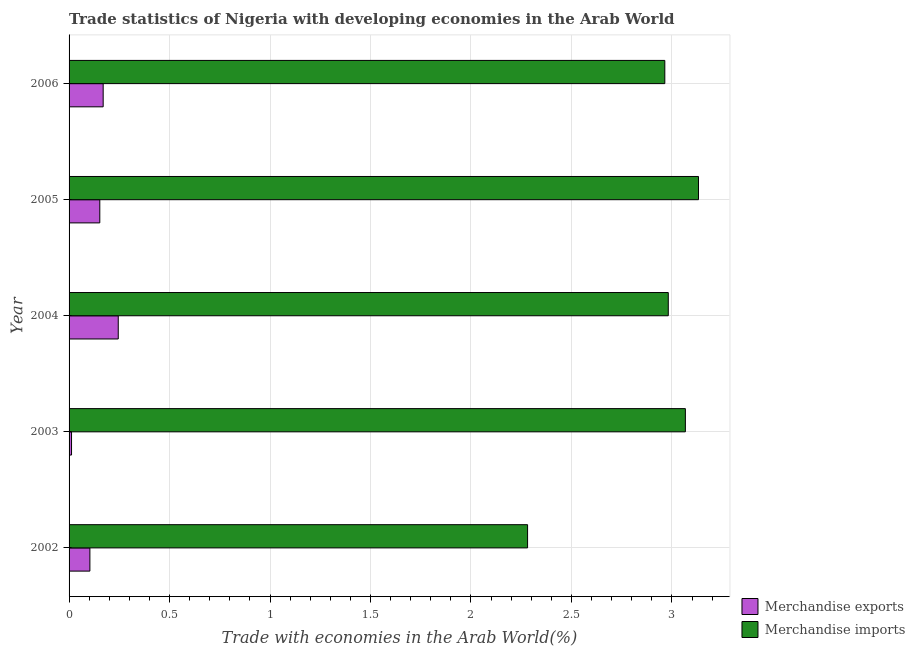How many bars are there on the 3rd tick from the top?
Provide a succinct answer. 2. What is the label of the 2nd group of bars from the top?
Give a very brief answer. 2005. In how many cases, is the number of bars for a given year not equal to the number of legend labels?
Your answer should be compact. 0. What is the merchandise exports in 2006?
Make the answer very short. 0.17. Across all years, what is the maximum merchandise exports?
Offer a very short reply. 0.24. Across all years, what is the minimum merchandise exports?
Your response must be concise. 0.01. In which year was the merchandise imports minimum?
Your answer should be compact. 2002. What is the total merchandise imports in the graph?
Your answer should be very brief. 14.43. What is the difference between the merchandise imports in 2004 and that in 2005?
Provide a succinct answer. -0.15. What is the difference between the merchandise exports in 2004 and the merchandise imports in 2003?
Give a very brief answer. -2.82. What is the average merchandise imports per year?
Provide a short and direct response. 2.89. In the year 2003, what is the difference between the merchandise exports and merchandise imports?
Offer a terse response. -3.06. What is the ratio of the merchandise exports in 2003 to that in 2006?
Make the answer very short. 0.07. Is the merchandise exports in 2002 less than that in 2003?
Provide a succinct answer. No. What is the difference between the highest and the second highest merchandise exports?
Your response must be concise. 0.07. Is the sum of the merchandise imports in 2003 and 2006 greater than the maximum merchandise exports across all years?
Offer a very short reply. Yes. What does the 1st bar from the top in 2005 represents?
Your answer should be compact. Merchandise imports. Are all the bars in the graph horizontal?
Offer a very short reply. Yes. How many years are there in the graph?
Your response must be concise. 5. What is the difference between two consecutive major ticks on the X-axis?
Offer a very short reply. 0.5. Are the values on the major ticks of X-axis written in scientific E-notation?
Your answer should be very brief. No. Does the graph contain grids?
Provide a short and direct response. Yes. Where does the legend appear in the graph?
Provide a short and direct response. Bottom right. How many legend labels are there?
Give a very brief answer. 2. What is the title of the graph?
Provide a short and direct response. Trade statistics of Nigeria with developing economies in the Arab World. Does "Long-term debt" appear as one of the legend labels in the graph?
Your answer should be compact. No. What is the label or title of the X-axis?
Your answer should be compact. Trade with economies in the Arab World(%). What is the label or title of the Y-axis?
Ensure brevity in your answer.  Year. What is the Trade with economies in the Arab World(%) of Merchandise exports in 2002?
Ensure brevity in your answer.  0.1. What is the Trade with economies in the Arab World(%) of Merchandise imports in 2002?
Your answer should be very brief. 2.28. What is the Trade with economies in the Arab World(%) in Merchandise exports in 2003?
Give a very brief answer. 0.01. What is the Trade with economies in the Arab World(%) of Merchandise imports in 2003?
Offer a very short reply. 3.07. What is the Trade with economies in the Arab World(%) of Merchandise exports in 2004?
Offer a very short reply. 0.24. What is the Trade with economies in the Arab World(%) in Merchandise imports in 2004?
Offer a very short reply. 2.98. What is the Trade with economies in the Arab World(%) in Merchandise exports in 2005?
Keep it short and to the point. 0.15. What is the Trade with economies in the Arab World(%) in Merchandise imports in 2005?
Give a very brief answer. 3.13. What is the Trade with economies in the Arab World(%) of Merchandise exports in 2006?
Your response must be concise. 0.17. What is the Trade with economies in the Arab World(%) in Merchandise imports in 2006?
Offer a very short reply. 2.96. Across all years, what is the maximum Trade with economies in the Arab World(%) in Merchandise exports?
Make the answer very short. 0.24. Across all years, what is the maximum Trade with economies in the Arab World(%) in Merchandise imports?
Offer a terse response. 3.13. Across all years, what is the minimum Trade with economies in the Arab World(%) of Merchandise exports?
Your answer should be compact. 0.01. Across all years, what is the minimum Trade with economies in the Arab World(%) in Merchandise imports?
Your response must be concise. 2.28. What is the total Trade with economies in the Arab World(%) in Merchandise exports in the graph?
Your answer should be compact. 0.68. What is the total Trade with economies in the Arab World(%) of Merchandise imports in the graph?
Your response must be concise. 14.43. What is the difference between the Trade with economies in the Arab World(%) in Merchandise exports in 2002 and that in 2003?
Your answer should be compact. 0.09. What is the difference between the Trade with economies in the Arab World(%) of Merchandise imports in 2002 and that in 2003?
Keep it short and to the point. -0.79. What is the difference between the Trade with economies in the Arab World(%) in Merchandise exports in 2002 and that in 2004?
Ensure brevity in your answer.  -0.14. What is the difference between the Trade with economies in the Arab World(%) in Merchandise imports in 2002 and that in 2004?
Make the answer very short. -0.7. What is the difference between the Trade with economies in the Arab World(%) in Merchandise exports in 2002 and that in 2005?
Your response must be concise. -0.05. What is the difference between the Trade with economies in the Arab World(%) of Merchandise imports in 2002 and that in 2005?
Offer a terse response. -0.85. What is the difference between the Trade with economies in the Arab World(%) of Merchandise exports in 2002 and that in 2006?
Make the answer very short. -0.07. What is the difference between the Trade with economies in the Arab World(%) in Merchandise imports in 2002 and that in 2006?
Give a very brief answer. -0.68. What is the difference between the Trade with economies in the Arab World(%) of Merchandise exports in 2003 and that in 2004?
Ensure brevity in your answer.  -0.23. What is the difference between the Trade with economies in the Arab World(%) in Merchandise imports in 2003 and that in 2004?
Offer a terse response. 0.09. What is the difference between the Trade with economies in the Arab World(%) in Merchandise exports in 2003 and that in 2005?
Your response must be concise. -0.14. What is the difference between the Trade with economies in the Arab World(%) in Merchandise imports in 2003 and that in 2005?
Make the answer very short. -0.07. What is the difference between the Trade with economies in the Arab World(%) in Merchandise exports in 2003 and that in 2006?
Provide a short and direct response. -0.16. What is the difference between the Trade with economies in the Arab World(%) in Merchandise imports in 2003 and that in 2006?
Offer a terse response. 0.1. What is the difference between the Trade with economies in the Arab World(%) in Merchandise exports in 2004 and that in 2005?
Keep it short and to the point. 0.09. What is the difference between the Trade with economies in the Arab World(%) in Merchandise imports in 2004 and that in 2005?
Your response must be concise. -0.15. What is the difference between the Trade with economies in the Arab World(%) of Merchandise exports in 2004 and that in 2006?
Provide a short and direct response. 0.07. What is the difference between the Trade with economies in the Arab World(%) of Merchandise imports in 2004 and that in 2006?
Offer a terse response. 0.02. What is the difference between the Trade with economies in the Arab World(%) in Merchandise exports in 2005 and that in 2006?
Provide a short and direct response. -0.02. What is the difference between the Trade with economies in the Arab World(%) of Merchandise imports in 2005 and that in 2006?
Give a very brief answer. 0.17. What is the difference between the Trade with economies in the Arab World(%) of Merchandise exports in 2002 and the Trade with economies in the Arab World(%) of Merchandise imports in 2003?
Your answer should be compact. -2.96. What is the difference between the Trade with economies in the Arab World(%) of Merchandise exports in 2002 and the Trade with economies in the Arab World(%) of Merchandise imports in 2004?
Keep it short and to the point. -2.88. What is the difference between the Trade with economies in the Arab World(%) in Merchandise exports in 2002 and the Trade with economies in the Arab World(%) in Merchandise imports in 2005?
Offer a terse response. -3.03. What is the difference between the Trade with economies in the Arab World(%) of Merchandise exports in 2002 and the Trade with economies in the Arab World(%) of Merchandise imports in 2006?
Your response must be concise. -2.86. What is the difference between the Trade with economies in the Arab World(%) of Merchandise exports in 2003 and the Trade with economies in the Arab World(%) of Merchandise imports in 2004?
Make the answer very short. -2.97. What is the difference between the Trade with economies in the Arab World(%) of Merchandise exports in 2003 and the Trade with economies in the Arab World(%) of Merchandise imports in 2005?
Offer a terse response. -3.12. What is the difference between the Trade with economies in the Arab World(%) in Merchandise exports in 2003 and the Trade with economies in the Arab World(%) in Merchandise imports in 2006?
Offer a terse response. -2.95. What is the difference between the Trade with economies in the Arab World(%) in Merchandise exports in 2004 and the Trade with economies in the Arab World(%) in Merchandise imports in 2005?
Give a very brief answer. -2.89. What is the difference between the Trade with economies in the Arab World(%) in Merchandise exports in 2004 and the Trade with economies in the Arab World(%) in Merchandise imports in 2006?
Offer a terse response. -2.72. What is the difference between the Trade with economies in the Arab World(%) in Merchandise exports in 2005 and the Trade with economies in the Arab World(%) in Merchandise imports in 2006?
Keep it short and to the point. -2.81. What is the average Trade with economies in the Arab World(%) of Merchandise exports per year?
Your answer should be very brief. 0.14. What is the average Trade with economies in the Arab World(%) in Merchandise imports per year?
Your answer should be compact. 2.89. In the year 2002, what is the difference between the Trade with economies in the Arab World(%) in Merchandise exports and Trade with economies in the Arab World(%) in Merchandise imports?
Provide a short and direct response. -2.18. In the year 2003, what is the difference between the Trade with economies in the Arab World(%) of Merchandise exports and Trade with economies in the Arab World(%) of Merchandise imports?
Give a very brief answer. -3.05. In the year 2004, what is the difference between the Trade with economies in the Arab World(%) of Merchandise exports and Trade with economies in the Arab World(%) of Merchandise imports?
Keep it short and to the point. -2.74. In the year 2005, what is the difference between the Trade with economies in the Arab World(%) of Merchandise exports and Trade with economies in the Arab World(%) of Merchandise imports?
Provide a succinct answer. -2.98. In the year 2006, what is the difference between the Trade with economies in the Arab World(%) in Merchandise exports and Trade with economies in the Arab World(%) in Merchandise imports?
Give a very brief answer. -2.79. What is the ratio of the Trade with economies in the Arab World(%) of Merchandise exports in 2002 to that in 2003?
Your answer should be compact. 8.47. What is the ratio of the Trade with economies in the Arab World(%) of Merchandise imports in 2002 to that in 2003?
Offer a very short reply. 0.74. What is the ratio of the Trade with economies in the Arab World(%) of Merchandise exports in 2002 to that in 2004?
Offer a terse response. 0.42. What is the ratio of the Trade with economies in the Arab World(%) in Merchandise imports in 2002 to that in 2004?
Give a very brief answer. 0.77. What is the ratio of the Trade with economies in the Arab World(%) in Merchandise exports in 2002 to that in 2005?
Your answer should be very brief. 0.68. What is the ratio of the Trade with economies in the Arab World(%) in Merchandise imports in 2002 to that in 2005?
Keep it short and to the point. 0.73. What is the ratio of the Trade with economies in the Arab World(%) of Merchandise exports in 2002 to that in 2006?
Make the answer very short. 0.61. What is the ratio of the Trade with economies in the Arab World(%) in Merchandise imports in 2002 to that in 2006?
Give a very brief answer. 0.77. What is the ratio of the Trade with economies in the Arab World(%) of Merchandise exports in 2003 to that in 2004?
Your answer should be very brief. 0.05. What is the ratio of the Trade with economies in the Arab World(%) in Merchandise imports in 2003 to that in 2004?
Offer a terse response. 1.03. What is the ratio of the Trade with economies in the Arab World(%) in Merchandise exports in 2003 to that in 2005?
Offer a very short reply. 0.08. What is the ratio of the Trade with economies in the Arab World(%) in Merchandise imports in 2003 to that in 2005?
Offer a terse response. 0.98. What is the ratio of the Trade with economies in the Arab World(%) of Merchandise exports in 2003 to that in 2006?
Your answer should be very brief. 0.07. What is the ratio of the Trade with economies in the Arab World(%) of Merchandise imports in 2003 to that in 2006?
Offer a terse response. 1.03. What is the ratio of the Trade with economies in the Arab World(%) of Merchandise exports in 2004 to that in 2005?
Your response must be concise. 1.6. What is the ratio of the Trade with economies in the Arab World(%) of Merchandise exports in 2004 to that in 2006?
Your answer should be compact. 1.44. What is the ratio of the Trade with economies in the Arab World(%) in Merchandise exports in 2005 to that in 2006?
Your answer should be compact. 0.9. What is the ratio of the Trade with economies in the Arab World(%) of Merchandise imports in 2005 to that in 2006?
Your answer should be compact. 1.06. What is the difference between the highest and the second highest Trade with economies in the Arab World(%) in Merchandise exports?
Your answer should be compact. 0.07. What is the difference between the highest and the second highest Trade with economies in the Arab World(%) of Merchandise imports?
Your answer should be very brief. 0.07. What is the difference between the highest and the lowest Trade with economies in the Arab World(%) of Merchandise exports?
Give a very brief answer. 0.23. What is the difference between the highest and the lowest Trade with economies in the Arab World(%) in Merchandise imports?
Make the answer very short. 0.85. 